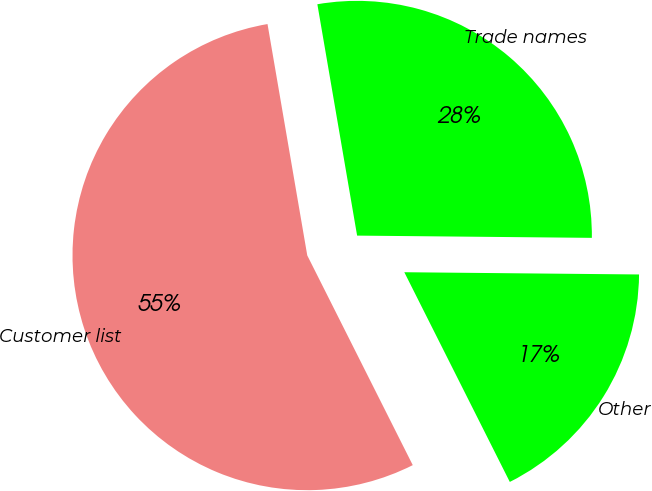<chart> <loc_0><loc_0><loc_500><loc_500><pie_chart><fcel>Customer list<fcel>Trade names<fcel>Other<nl><fcel>54.71%<fcel>27.86%<fcel>17.43%<nl></chart> 